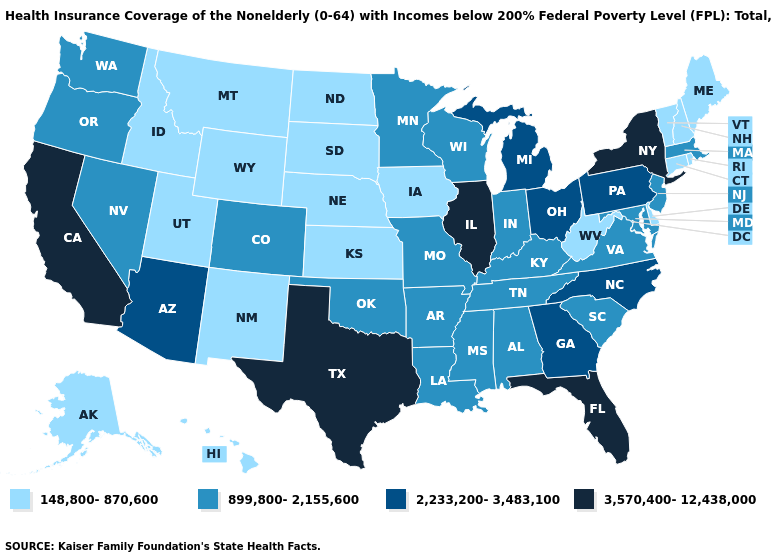Among the states that border Vermont , which have the highest value?
Short answer required. New York. What is the value of Nebraska?
Short answer required. 148,800-870,600. Is the legend a continuous bar?
Concise answer only. No. Name the states that have a value in the range 3,570,400-12,438,000?
Quick response, please. California, Florida, Illinois, New York, Texas. Name the states that have a value in the range 3,570,400-12,438,000?
Keep it brief. California, Florida, Illinois, New York, Texas. Does Florida have the highest value in the USA?
Be succinct. Yes. Which states have the lowest value in the USA?
Give a very brief answer. Alaska, Connecticut, Delaware, Hawaii, Idaho, Iowa, Kansas, Maine, Montana, Nebraska, New Hampshire, New Mexico, North Dakota, Rhode Island, South Dakota, Utah, Vermont, West Virginia, Wyoming. Name the states that have a value in the range 3,570,400-12,438,000?
Quick response, please. California, Florida, Illinois, New York, Texas. Does the first symbol in the legend represent the smallest category?
Quick response, please. Yes. What is the lowest value in the USA?
Concise answer only. 148,800-870,600. Does West Virginia have the same value as Wyoming?
Short answer required. Yes. What is the highest value in the USA?
Answer briefly. 3,570,400-12,438,000. Does Iowa have the lowest value in the USA?
Concise answer only. Yes. Among the states that border New York , does Pennsylvania have the lowest value?
Give a very brief answer. No. Does the first symbol in the legend represent the smallest category?
Concise answer only. Yes. 